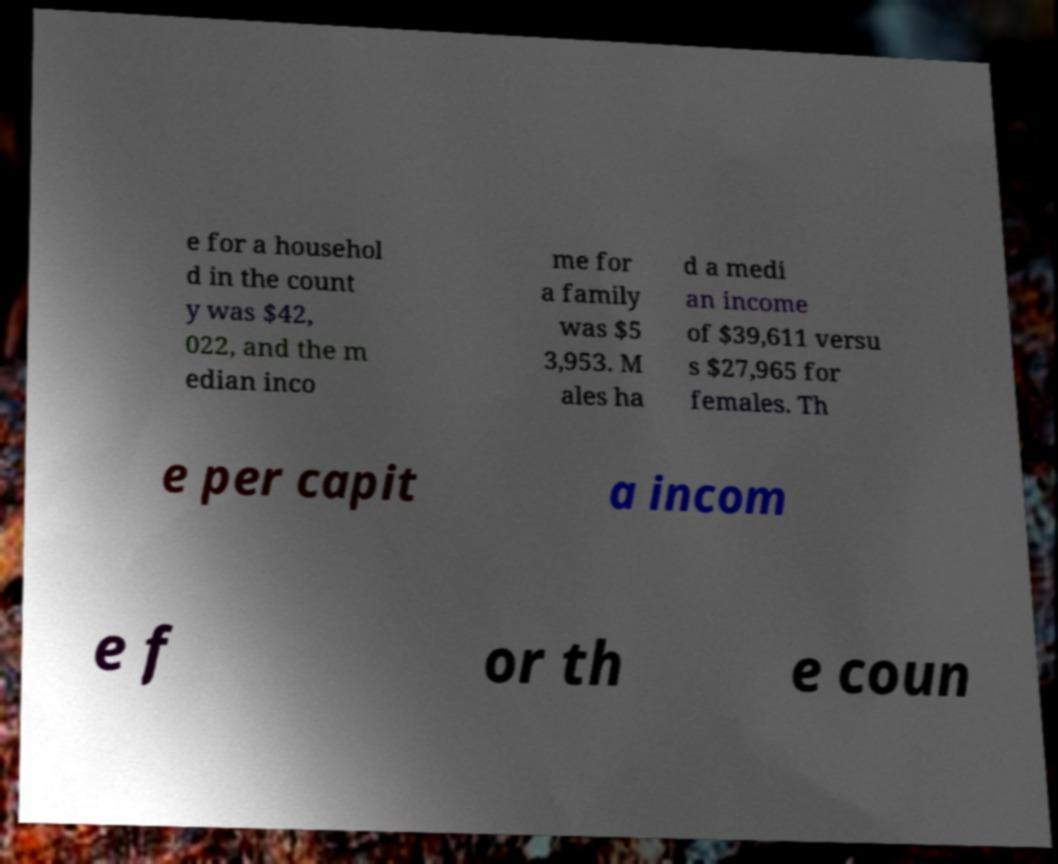Please read and relay the text visible in this image. What does it say? e for a househol d in the count y was $42, 022, and the m edian inco me for a family was $5 3,953. M ales ha d a medi an income of $39,611 versu s $27,965 for females. Th e per capit a incom e f or th e coun 